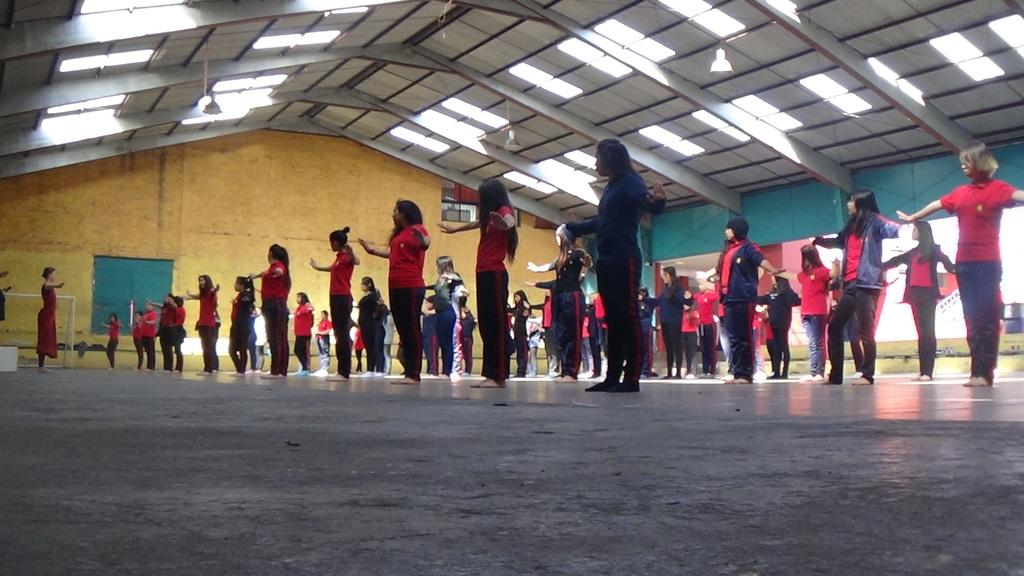How many people are in the image? There is a group of people in the image. Where are the people standing in the image? The people are standing on the floor, wall, and roof in the image. What else can be seen in the image besides the people? There are objects present in the image. What type of knowledge is being shared among the people in the image? There is no indication in the image of any knowledge being shared among the people. 